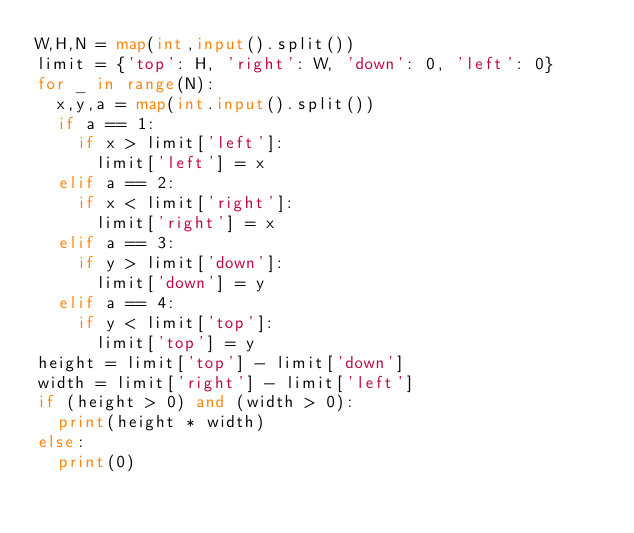<code> <loc_0><loc_0><loc_500><loc_500><_Python_>W,H,N = map(int,input().split())
limit = {'top': H, 'right': W, 'down': 0, 'left': 0}
for _ in range(N):
  x,y,a = map(int.input().split())
  if a == 1:
    if x > limit['left']:
      limit['left'] = x
  elif a == 2:
    if x < limit['right']:
      limit['right'] = x
  elif a == 3:
    if y > limit['down']:
      limit['down'] = y
  elif a == 4:
    if y < limit['top']:
      limit['top'] = y
height = limit['top'] - limit['down']
width = limit['right'] - limit['left']
if (height > 0) and (width > 0):
  print(height * width)
else:
  print(0)
  </code> 